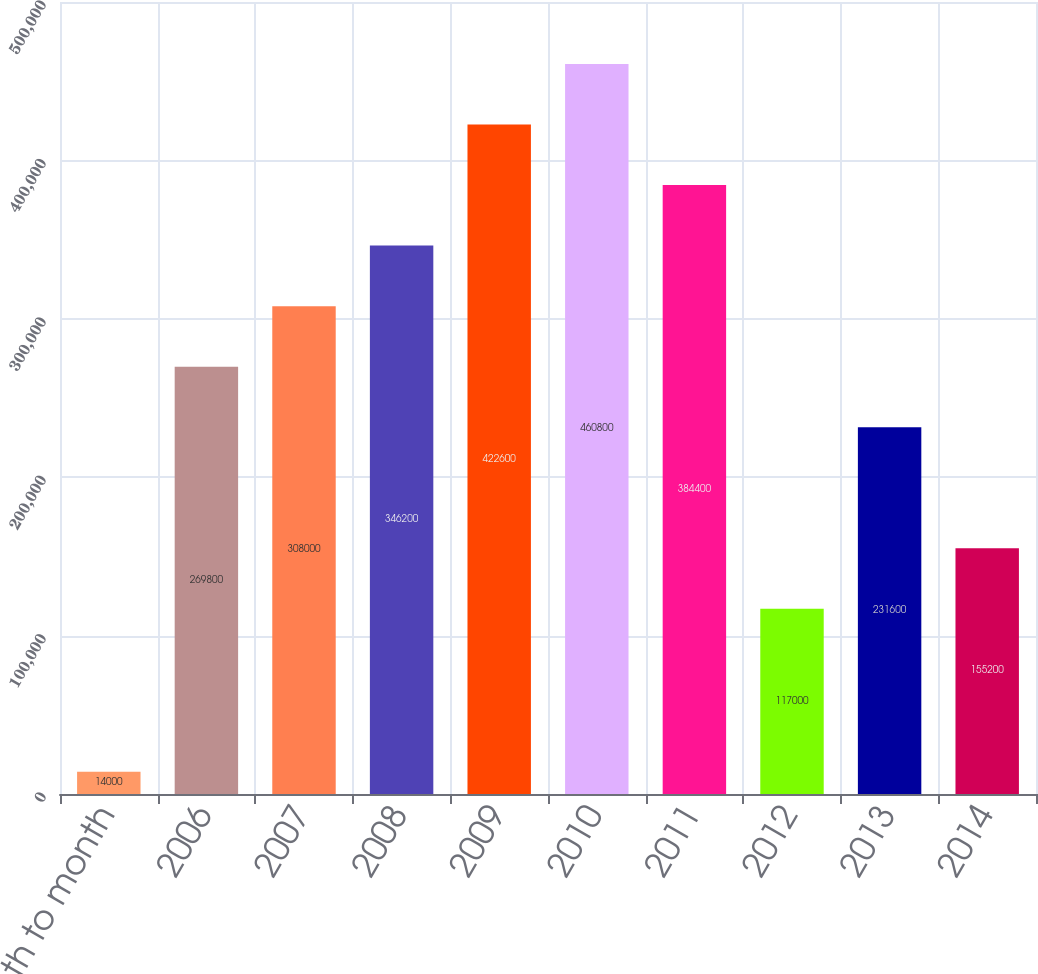Convert chart to OTSL. <chart><loc_0><loc_0><loc_500><loc_500><bar_chart><fcel>Month to month<fcel>2006<fcel>2007<fcel>2008<fcel>2009<fcel>2010<fcel>2011<fcel>2012<fcel>2013<fcel>2014<nl><fcel>14000<fcel>269800<fcel>308000<fcel>346200<fcel>422600<fcel>460800<fcel>384400<fcel>117000<fcel>231600<fcel>155200<nl></chart> 